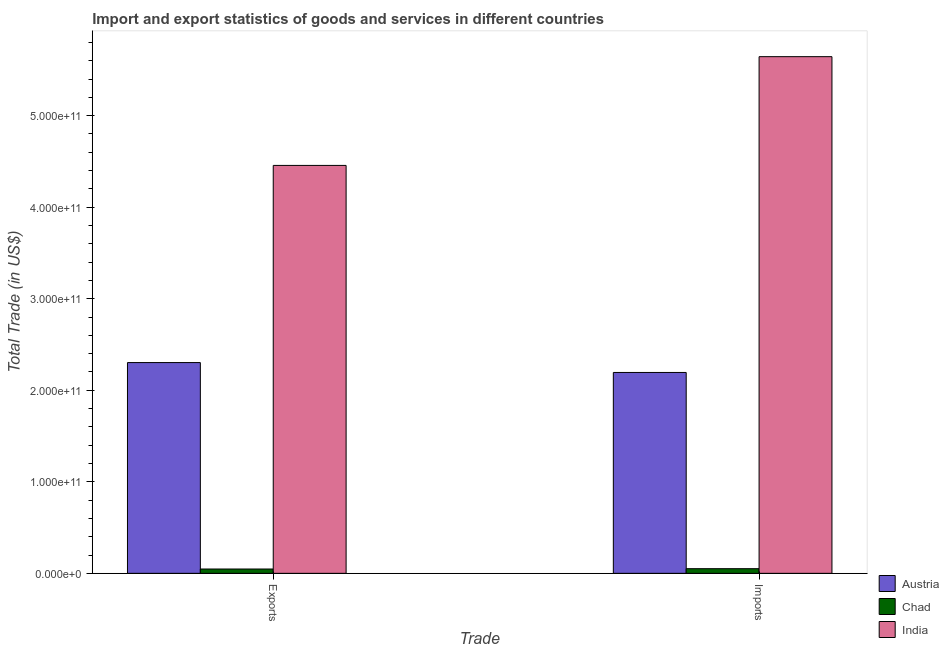How many groups of bars are there?
Offer a terse response. 2. Are the number of bars per tick equal to the number of legend labels?
Your answer should be very brief. Yes. How many bars are there on the 2nd tick from the left?
Your response must be concise. 3. How many bars are there on the 2nd tick from the right?
Your answer should be compact. 3. What is the label of the 2nd group of bars from the left?
Offer a terse response. Imports. What is the export of goods and services in India?
Offer a very short reply. 4.46e+11. Across all countries, what is the maximum export of goods and services?
Give a very brief answer. 4.46e+11. Across all countries, what is the minimum imports of goods and services?
Keep it short and to the point. 5.08e+09. In which country was the imports of goods and services minimum?
Provide a short and direct response. Chad. What is the total imports of goods and services in the graph?
Provide a succinct answer. 7.89e+11. What is the difference between the imports of goods and services in India and that in Austria?
Make the answer very short. 3.45e+11. What is the difference between the export of goods and services in Austria and the imports of goods and services in India?
Keep it short and to the point. -3.34e+11. What is the average export of goods and services per country?
Make the answer very short. 2.27e+11. What is the difference between the imports of goods and services and export of goods and services in Chad?
Provide a succinct answer. 3.56e+08. In how many countries, is the imports of goods and services greater than 240000000000 US$?
Your response must be concise. 1. What is the ratio of the export of goods and services in Chad to that in India?
Your answer should be very brief. 0.01. What does the 1st bar from the left in Exports represents?
Your answer should be very brief. Austria. What does the 1st bar from the right in Exports represents?
Keep it short and to the point. India. How many bars are there?
Your answer should be very brief. 6. What is the difference between two consecutive major ticks on the Y-axis?
Keep it short and to the point. 1.00e+11. Are the values on the major ticks of Y-axis written in scientific E-notation?
Provide a short and direct response. Yes. How many legend labels are there?
Give a very brief answer. 3. What is the title of the graph?
Keep it short and to the point. Import and export statistics of goods and services in different countries. Does "Barbados" appear as one of the legend labels in the graph?
Offer a very short reply. No. What is the label or title of the X-axis?
Your answer should be very brief. Trade. What is the label or title of the Y-axis?
Offer a terse response. Total Trade (in US$). What is the Total Trade (in US$) in Austria in Exports?
Provide a succinct answer. 2.30e+11. What is the Total Trade (in US$) of Chad in Exports?
Your answer should be very brief. 4.73e+09. What is the Total Trade (in US$) of India in Exports?
Offer a terse response. 4.46e+11. What is the Total Trade (in US$) of Austria in Imports?
Make the answer very short. 2.19e+11. What is the Total Trade (in US$) in Chad in Imports?
Keep it short and to the point. 5.08e+09. What is the Total Trade (in US$) in India in Imports?
Offer a terse response. 5.64e+11. Across all Trade, what is the maximum Total Trade (in US$) of Austria?
Your response must be concise. 2.30e+11. Across all Trade, what is the maximum Total Trade (in US$) in Chad?
Your answer should be very brief. 5.08e+09. Across all Trade, what is the maximum Total Trade (in US$) in India?
Your answer should be compact. 5.64e+11. Across all Trade, what is the minimum Total Trade (in US$) of Austria?
Provide a succinct answer. 2.19e+11. Across all Trade, what is the minimum Total Trade (in US$) of Chad?
Provide a short and direct response. 4.73e+09. Across all Trade, what is the minimum Total Trade (in US$) in India?
Provide a short and direct response. 4.46e+11. What is the total Total Trade (in US$) of Austria in the graph?
Provide a short and direct response. 4.50e+11. What is the total Total Trade (in US$) of Chad in the graph?
Your answer should be very brief. 9.81e+09. What is the total Total Trade (in US$) in India in the graph?
Offer a very short reply. 1.01e+12. What is the difference between the Total Trade (in US$) in Austria in Exports and that in Imports?
Ensure brevity in your answer.  1.08e+1. What is the difference between the Total Trade (in US$) in Chad in Exports and that in Imports?
Your answer should be compact. -3.56e+08. What is the difference between the Total Trade (in US$) in India in Exports and that in Imports?
Make the answer very short. -1.19e+11. What is the difference between the Total Trade (in US$) in Austria in Exports and the Total Trade (in US$) in Chad in Imports?
Provide a short and direct response. 2.25e+11. What is the difference between the Total Trade (in US$) in Austria in Exports and the Total Trade (in US$) in India in Imports?
Your answer should be compact. -3.34e+11. What is the difference between the Total Trade (in US$) in Chad in Exports and the Total Trade (in US$) in India in Imports?
Your response must be concise. -5.60e+11. What is the average Total Trade (in US$) in Austria per Trade?
Your answer should be very brief. 2.25e+11. What is the average Total Trade (in US$) in Chad per Trade?
Ensure brevity in your answer.  4.90e+09. What is the average Total Trade (in US$) in India per Trade?
Your answer should be compact. 5.05e+11. What is the difference between the Total Trade (in US$) in Austria and Total Trade (in US$) in Chad in Exports?
Offer a terse response. 2.26e+11. What is the difference between the Total Trade (in US$) of Austria and Total Trade (in US$) of India in Exports?
Provide a short and direct response. -2.15e+11. What is the difference between the Total Trade (in US$) in Chad and Total Trade (in US$) in India in Exports?
Your answer should be very brief. -4.41e+11. What is the difference between the Total Trade (in US$) of Austria and Total Trade (in US$) of Chad in Imports?
Provide a succinct answer. 2.14e+11. What is the difference between the Total Trade (in US$) of Austria and Total Trade (in US$) of India in Imports?
Your answer should be very brief. -3.45e+11. What is the difference between the Total Trade (in US$) of Chad and Total Trade (in US$) of India in Imports?
Offer a very short reply. -5.59e+11. What is the ratio of the Total Trade (in US$) in Austria in Exports to that in Imports?
Your answer should be compact. 1.05. What is the ratio of the Total Trade (in US$) in India in Exports to that in Imports?
Keep it short and to the point. 0.79. What is the difference between the highest and the second highest Total Trade (in US$) of Austria?
Your response must be concise. 1.08e+1. What is the difference between the highest and the second highest Total Trade (in US$) in Chad?
Provide a short and direct response. 3.56e+08. What is the difference between the highest and the second highest Total Trade (in US$) of India?
Ensure brevity in your answer.  1.19e+11. What is the difference between the highest and the lowest Total Trade (in US$) of Austria?
Give a very brief answer. 1.08e+1. What is the difference between the highest and the lowest Total Trade (in US$) of Chad?
Keep it short and to the point. 3.56e+08. What is the difference between the highest and the lowest Total Trade (in US$) in India?
Keep it short and to the point. 1.19e+11. 